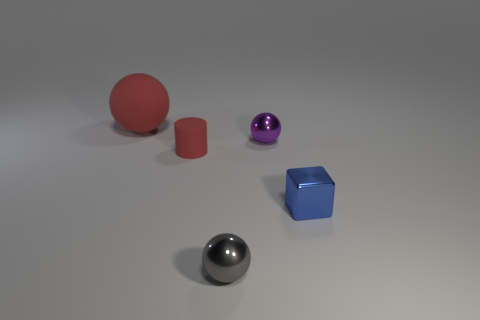Add 2 blue balls. How many objects exist? 7 Subtract all brown blocks. Subtract all red spheres. How many blocks are left? 1 Subtract all blocks. How many objects are left? 4 Add 2 small blocks. How many small blocks exist? 3 Subtract 0 cyan cubes. How many objects are left? 5 Subtract all large red things. Subtract all red rubber cylinders. How many objects are left? 3 Add 1 purple balls. How many purple balls are left? 2 